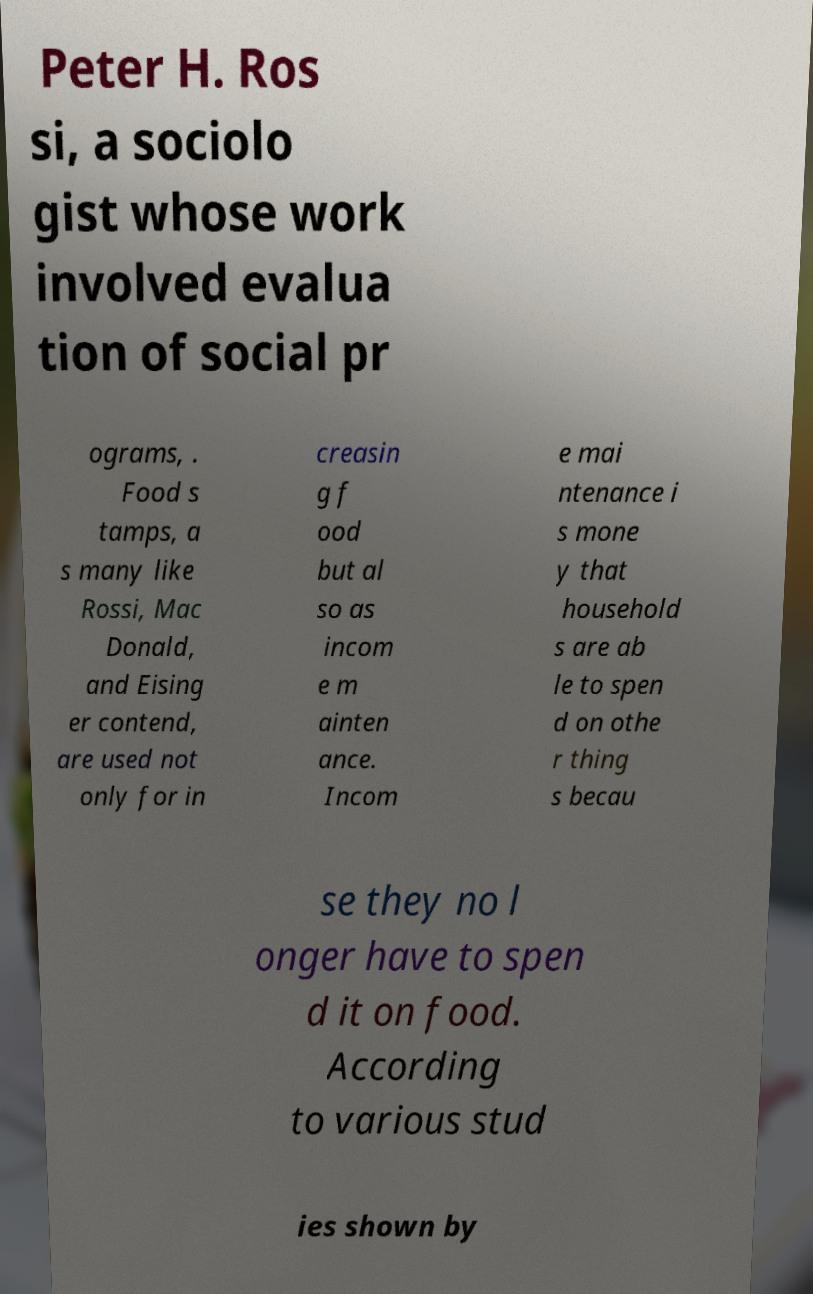What messages or text are displayed in this image? I need them in a readable, typed format. Peter H. Ros si, a sociolo gist whose work involved evalua tion of social pr ograms, . Food s tamps, a s many like Rossi, Mac Donald, and Eising er contend, are used not only for in creasin g f ood but al so as incom e m ainten ance. Incom e mai ntenance i s mone y that household s are ab le to spen d on othe r thing s becau se they no l onger have to spen d it on food. According to various stud ies shown by 